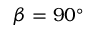<formula> <loc_0><loc_0><loc_500><loc_500>\beta = 9 0 ^ { \circ }</formula> 